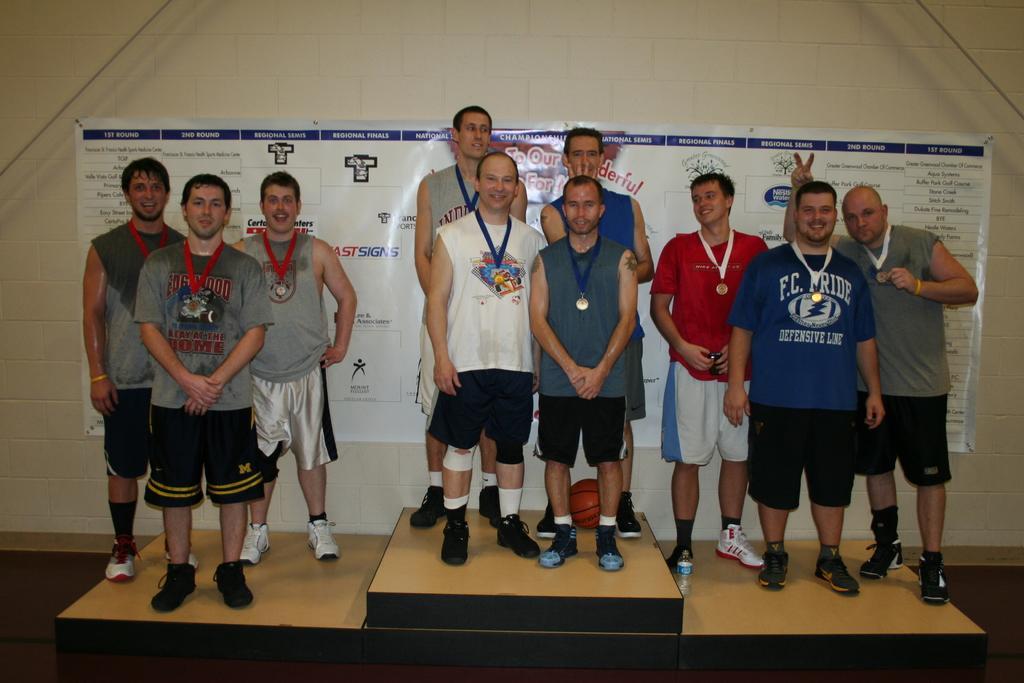In one or two sentences, can you explain what this image depicts? In this image there are group of people standing and there is one ball, in the background there is one board on the wall. And on the right side and left side there are ropes. 